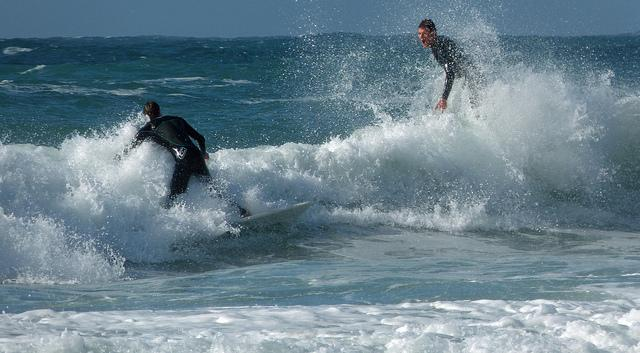Why is the surfer wearing a wetsuit?

Choices:
A) fashion
B) prevent sunburn
C) visibility
D) insulation insulation 